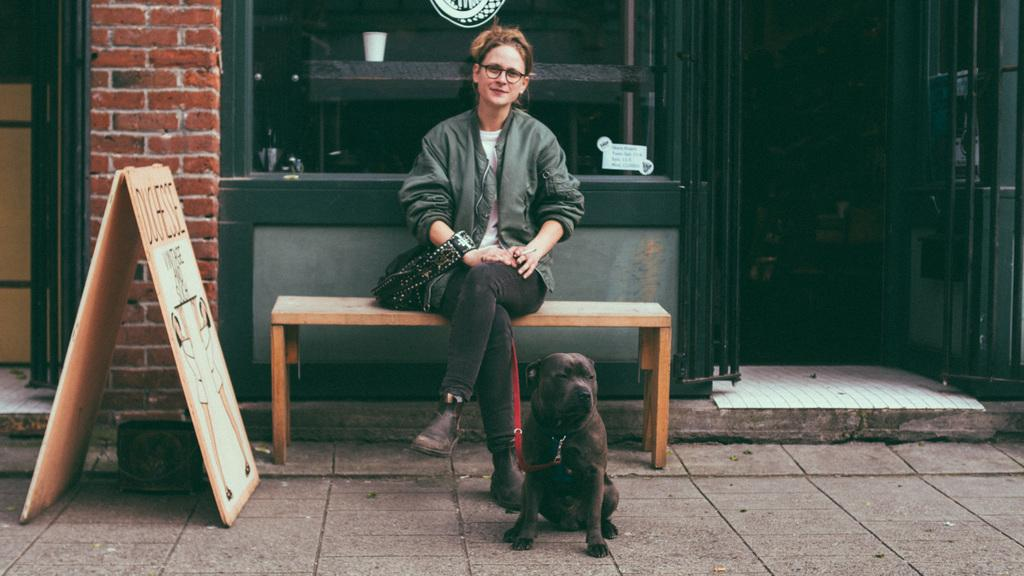Who is present in the image? There is a woman in the image. What is the woman doing in the image? The woman is sitting on a bench. What other living creature is in the image? There is a dog in the image. Where is the dog located in the image? The dog is sitting on the floor. What can be seen in the background of the image? There is a building in the background of the image. How much money does the woman owe the dog in the image? There is no indication of any debt or money exchange in the image; it simply shows a woman sitting on a bench and a dog sitting on the floor. 